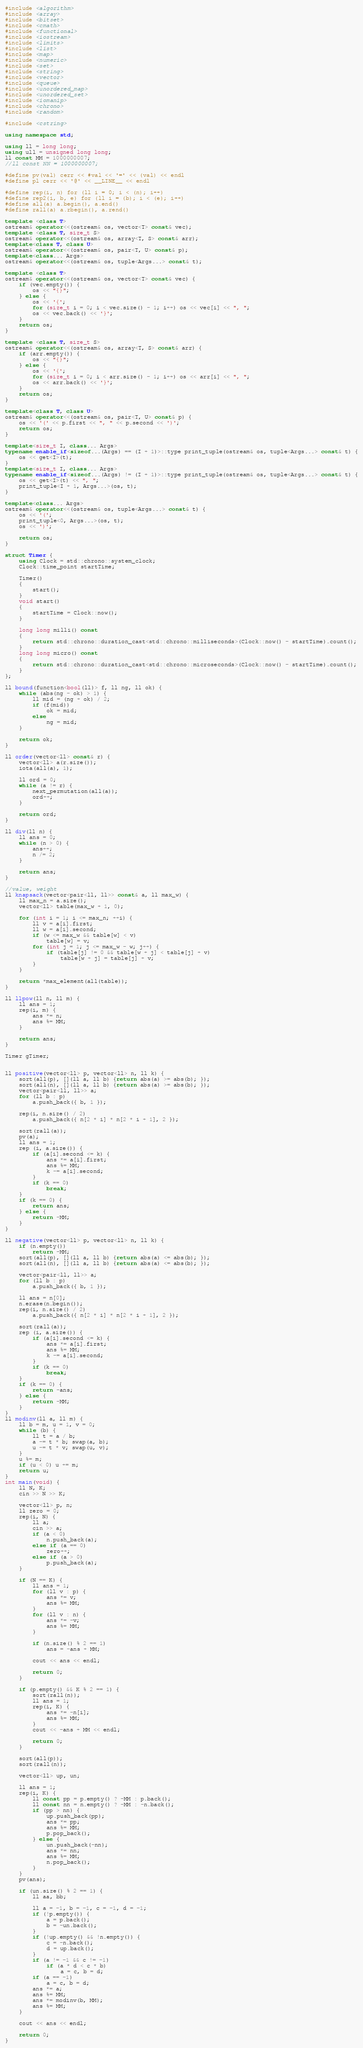<code> <loc_0><loc_0><loc_500><loc_500><_C++_>#include <algorithm>
#include <array>
#include <bitset>
#include <cmath>
#include <functional>
#include <iostream>
#include <limits>
#include <list>
#include <map>
#include <numeric>
#include <set>
#include <string>
#include <vector>
#include <queue>
#include <unordered_map>
#include <unordered_set>
#include <iomanip>
#include <chrono>
#include <random>

#include <cstring>

using namespace std;

using ll = long long;
using ull = unsigned long long;
ll const MM = 1000000007;
//ll const NN = 1000000007;

#define pv(val) cerr << #val << '=' << (val) << endl
#define pl cerr << '@' << __LINE__ << endl

#define rep(i, n) for (ll i = 0; i < (n); i++)
#define rep2(i, b, e) for (ll i = (b); i < (e); i++)
#define all(a) a.begin(), a.end()
#define rall(a) a.rbegin(), a.rend()

template <class T>
ostream& operator<<(ostream& os, vector<T> const& vec);
template <class T, size_t S>
ostream& operator<<(ostream& os, array<T, S> const& arr);
template<class T, class U>
ostream& operator<<(ostream& os, pair<T, U> const& p);
template<class... Args>
ostream& operator<<(ostream& os, tuple<Args...> const& t);

template <class T>
ostream& operator<<(ostream& os, vector<T> const& vec) {
    if (vec.empty()) {
        os << "{}";
    } else {
        os << '{';
        for (size_t i = 0; i < vec.size() - 1; i++) os << vec[i] << ", ";
        os << vec.back() << '}';
    }
    return os;
}

template <class T, size_t S>
ostream& operator<<(ostream& os, array<T, S> const& arr) {
    if (arr.empty()) {
        os << "{}";
    } else {
        os << '{';
        for (size_t i = 0; i < arr.size() - 1; i++) os << arr[i] << ", ";
        os << arr.back() << '}';
    }
    return os;
}

template<class T, class U>
ostream& operator<<(ostream& os, pair<T, U> const& p) {
    os << '(' << p.first << ", " << p.second << ')';
    return os;
}

template<size_t I, class... Args>
typename enable_if<sizeof...(Args) == (I + 1)>::type print_tuple(ostream& os, tuple<Args...> const& t) {
    os << get<I>(t);
}
template<size_t I, class... Args>
typename enable_if<sizeof...(Args) != (I + 1)>::type print_tuple(ostream& os, tuple<Args...> const& t) {
    os << get<I>(t) << ", ";
    print_tuple<I + 1, Args...>(os, t);
}

template<class... Args>
ostream& operator<<(ostream& os, tuple<Args...> const& t) {
    os << '(';
    print_tuple<0, Args...>(os, t);
    os << ')';

    return os;
}

struct Timer {
    using Clock = std::chrono::system_clock;
    Clock::time_point startTime;
 
    Timer()
    {
        start();
    }
    void start()
    {
        startTime = Clock::now();
    }
 
    long long milli() const
    {
        return std::chrono::duration_cast<std::chrono::milliseconds>(Clock::now() - startTime).count();
    }
    long long micro() const
    {
        return std::chrono::duration_cast<std::chrono::microseconds>(Clock::now() - startTime).count();
    }
};

ll bound(function<bool(ll)> f, ll ng, ll ok) {
    while (abs(ng - ok) > 1) {
        ll mid = (ng + ok) / 2;
        if (f(mid))
            ok = mid;
        else
            ng = mid;
    }

    return ok;
}

ll order(vector<ll> const& r) {
    vector<ll> a(r.size());
    iota(all(a), 1);

    ll ord = 0;
    while (a != r) {
        next_permutation(all(a));
        ord++;
    }

    return ord;
}

ll div(ll n) {
    ll ans = 0;
    while (n > 0) {
        ans++;
        n /= 2;
    }

    return ans;
}

//value, weight
ll knapsack(vector<pair<ll, ll>> const& a, ll max_w) {
    ll max_n = a.size();
    vector<ll> table(max_w + 1, 0);

    for (int i = 1; i <= max_n; ++i) {
        ll v = a[i].first;
        ll w = a[i].second;
        if (w <= max_w && table[w] < v)
            table[w] = v;
        for (int j = 1; j <= max_w - w; j++) {
            if (table[j] != 0 && table[w + j] < table[j] + v)
                table[w + j] = table[j] + v;
        }
    }

    return *max_element(all(table));
}

ll llpow(ll n, ll m) {
    ll ans = 1;
    rep(i, m) {
        ans *= n;
        ans %= MM;
    }

    return ans;
}

Timer gTimer;


ll positive(vector<ll> p, vector<ll> n, ll k) {
    sort(all(p), [](ll a, ll b) {return abs(a) >= abs(b); });
    sort(all(n), [](ll a, ll b) {return abs(a) >= abs(b); });
    vector<pair<ll, ll>> a;
    for (ll b : p)
        a.push_back({ b, 1 });

    rep(i, n.size() / 2)
        a.push_back({ n[2 * i] * n[2 * i + 1], 2 });

    sort(rall(a));
    pv(a);
    ll ans = 1;
    rep (i, a.size()) {
        if (a[i].second <= k) {
            ans *= a[i].first;
            ans %= MM;
            k -= a[i].second;
        }
        if (k == 0)
            break;
    }
    if (k == 0) {
        return ans;
    } else {
        return -MM;
    }
}

ll negative(vector<ll> p, vector<ll> n, ll k) {
    if (n.empty())
        return -MM;
    sort(all(p), [](ll a, ll b) {return abs(a) <= abs(b); });
    sort(all(n), [](ll a, ll b) {return abs(a) <= abs(b); });

    vector<pair<ll, ll>> a;
    for (ll b : p)
        a.push_back({ b, 1 });

    ll ans = n[0];
    n.erase(n.begin());
    rep(i, n.size() / 2)
        a.push_back({ n[2 * i] * n[2 * i + 1], 2 });

    sort(rall(a));
    rep (i, a.size()) {
        if (a[i].second <= k) {
            ans *= a[i].first;
            ans %= MM;
            k -= a[i].second;
        }
        if (k == 0)
            break;
    }
    if (k == 0) {
        return -ans;
    } else {
        return -MM;
    }
}
ll modinv(ll a, ll m) {
    ll b = m, u = 1, v = 0;
    while (b) {
        ll t = a / b;
        a -= t * b; swap(a, b);
        u -= t * v; swap(u, v);
    }
    u %= m;
    if (u < 0) u += m;
    return u;
}
int main(void) {
    ll N, K;
    cin >> N >> K;

    vector<ll> p, n;
    ll zero = 0;
    rep(i, N) {
        ll a;
        cin >> a;
        if (a < 0)
            n.push_back(a);
        else if (a == 0)
            zero++;
        else if (a > 0)
            p.push_back(a);
    }

    if (N == K) {
        ll ans = 1;
        for (ll v : p) {
            ans *= v;
            ans %= MM;
        }
        for (ll v : n) {
            ans *= -v;
            ans %= MM;
        }

        if (n.size() % 2 == 1)
            ans = -ans + MM;

        cout << ans << endl;

        return 0;
    }

    if (p.empty() && K % 2 == 1) {
        sort(rall(n));
        ll ans = 1;
        rep(i, K) {
            ans *= -n[i];
            ans %= MM;
        }
        cout << -ans + MM << endl;

        return 0;
    }

    sort(all(p));
    sort(rall(n));

    vector<ll> up, un;

    ll ans = 1;
    rep(i, K) {
        ll const pp = p.empty() ? -MM : p.back();
        ll const nn = n.empty() ? -MM : -n.back();
        if (pp > nn) {
            up.push_back(pp);
            ans *= pp;
            ans %= MM;
            p.pop_back();
        } else {
            un.push_back(-nn);
            ans *= nn;
            ans %= MM;
            n.pop_back();
        }
    }
    pv(ans);

    if (un.size() % 2 == 1) {
        ll aa, bb;

        ll a = -1, b = -1, c = -1, d = -1;
        if (!p.empty()) {
            a = p.back();
            b = -un.back();
        }
        if (!up.empty() && !n.empty()) {
            c = -n.back();
            d = up.back();
        }
        if (a != -1 && c != -1)
            if (a * d < c * b)
                a = c, b = d;
        if (a == -1)
            a = c, b = d;
        ans *= a;
        ans %= MM;
        ans *= modinv(b, MM);
        ans %= MM;
    }

    cout << ans << endl;

    return 0;
}

</code> 